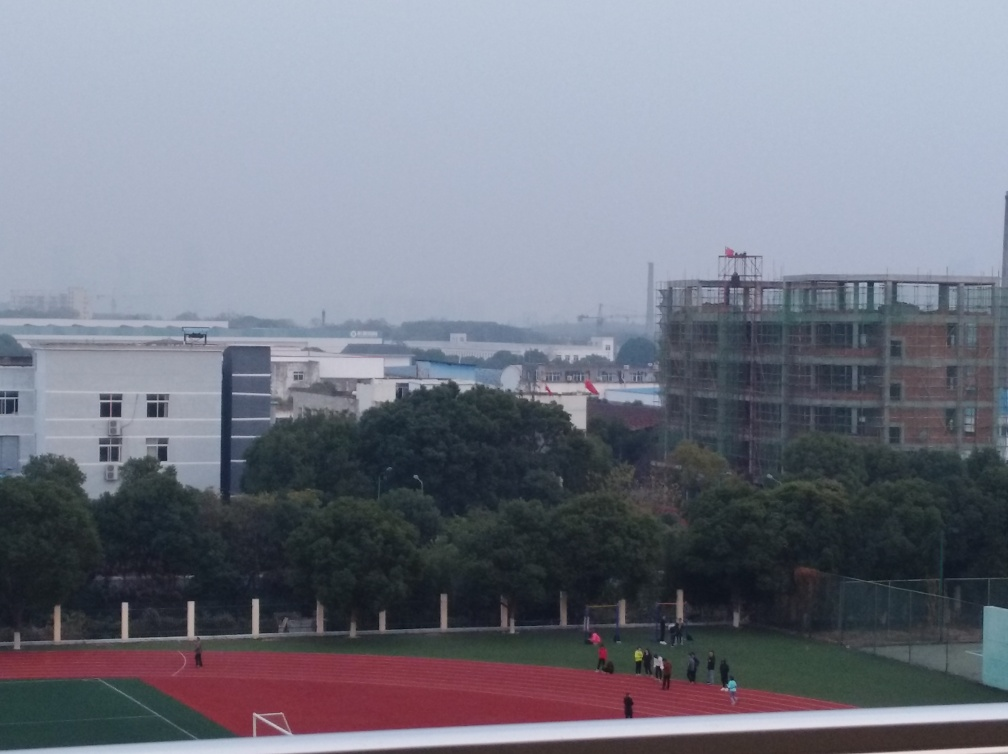What details are missing from the main subject? The image seems to be lacking sharpness and clarity, which can make it difficult to discern finer details. Depth, contrast, and vibrancy are also subdued, leading to a flatter, less dynamic visual presentation. 